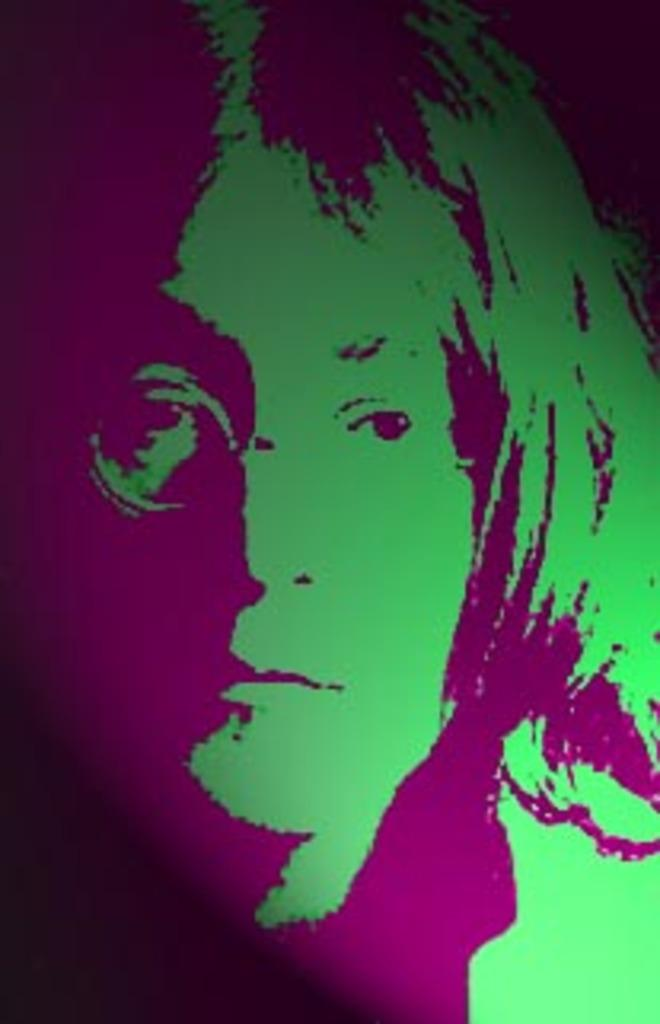Who is present in the image? There is a woman in the image. What type of test is the woman conducting in the image? There is no test present in the image; it only features a woman. What type of office is depicted in the image? There is no office depicted in the image; it only features a woman. 